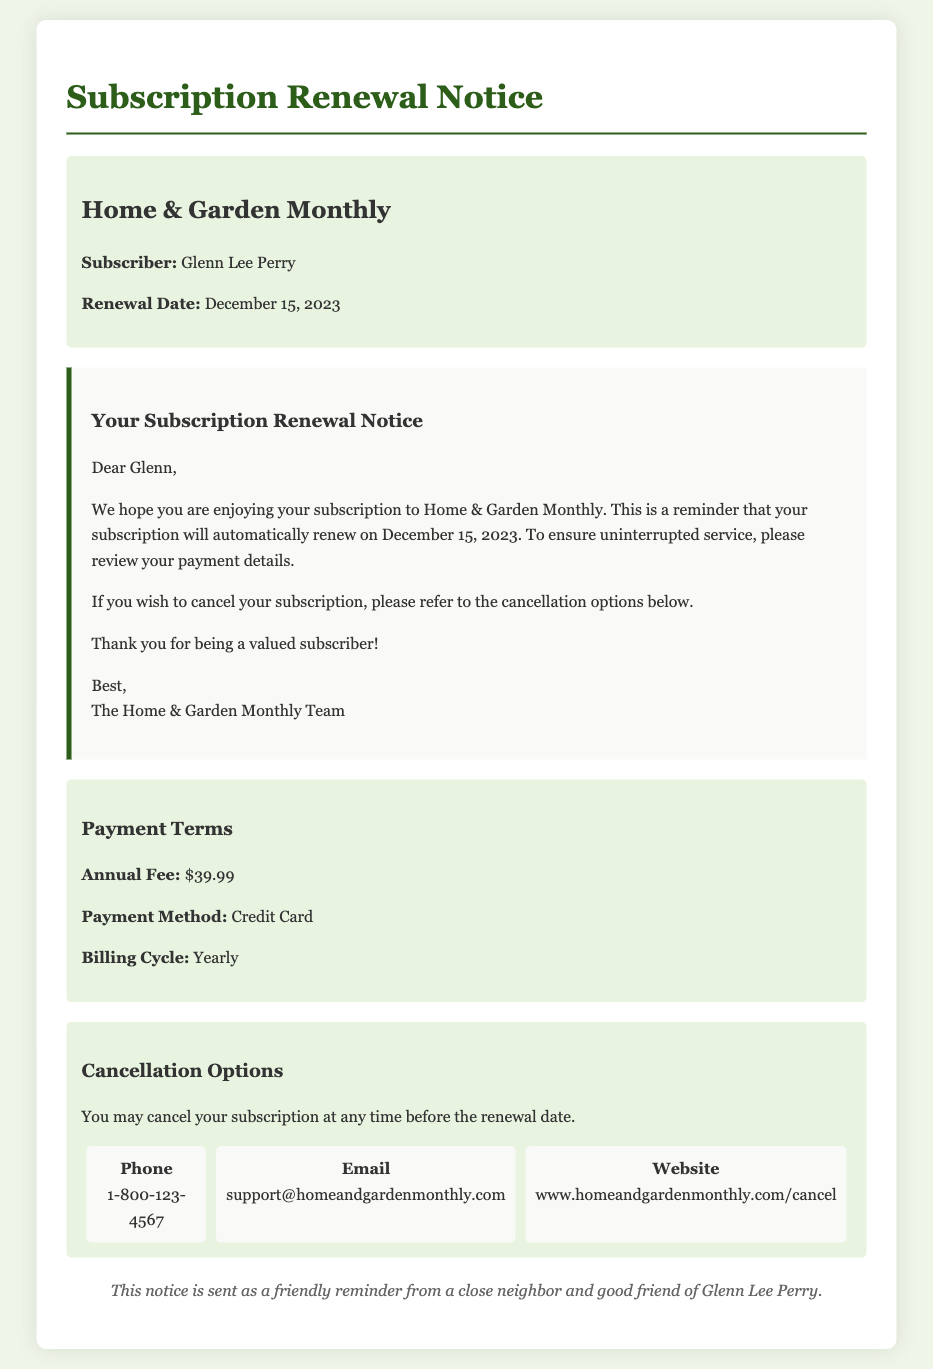What is the name of the magazine? The document specifies that the magazine is named "Home & Garden Monthly."
Answer: Home & Garden Monthly Who is the subscriber? The notice directly mentions the subscriber's name as "Glenn Lee Perry."
Answer: Glenn Lee Perry What is the renewal date? The document states that the renewal date is "December 15, 2023."
Answer: December 15, 2023 What is the annual fee for the subscription? The payment terms section indicates that the annual fee is "$39.99."
Answer: $39.99 How can Glenn cancel his subscription? The document states that he may cancel his subscription by referring to the cancellation options mentioned below.
Answer: At any time before the renewal date What is the payment method? The payment terms section specifies that the payment method is "Credit Card."
Answer: Credit Card What information is provided for cancellation via phone? The document includes a phone number for cancellation, which is "1-800-123-4567."
Answer: 1-800-123-4567 Is there an email address for support? The document lists an email address for support, which is "support@homeandgardenmonthly.com."
Answer: support@homeandgardenmonthly.com What is the billing cycle for the subscription? The billing cycle stated in the payment terms is "Yearly."
Answer: Yearly 